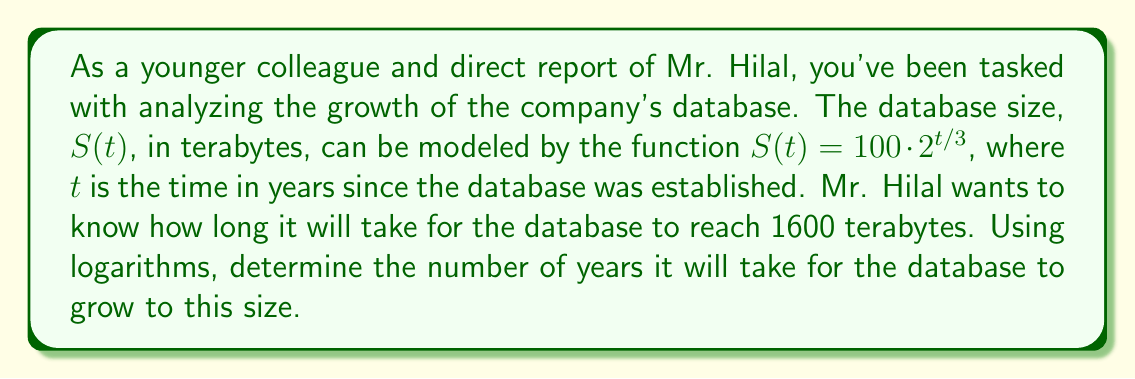What is the answer to this math problem? To solve this problem, we'll use the given function and logarithms. Let's approach this step-by-step:

1) We're given the function $S(t) = 100 \cdot 2^{t/3}$, where $S(t)$ is the size in terabytes and $t$ is the time in years.

2) We want to find $t$ when $S(t) = 1600$. So, let's set up the equation:

   $$1600 = 100 \cdot 2^{t/3}$$

3) First, let's divide both sides by 100:

   $$16 = 2^{t/3}$$

4) Now, we can apply the logarithm (base 2) to both sides:

   $$\log_2(16) = \log_2(2^{t/3})$$

5) Using the logarithm property $\log_a(a^x) = x$, we can simplify the right side:

   $$\log_2(16) = t/3$$

6) We know that $\log_2(16) = 4$ (since $2^4 = 16$), so:

   $$4 = t/3$$

7) Finally, we can solve for $t$ by multiplying both sides by 3:

   $$t = 4 \cdot 3 = 12$$

Therefore, it will take 12 years for the database to reach 1600 terabytes.
Answer: 12 years 